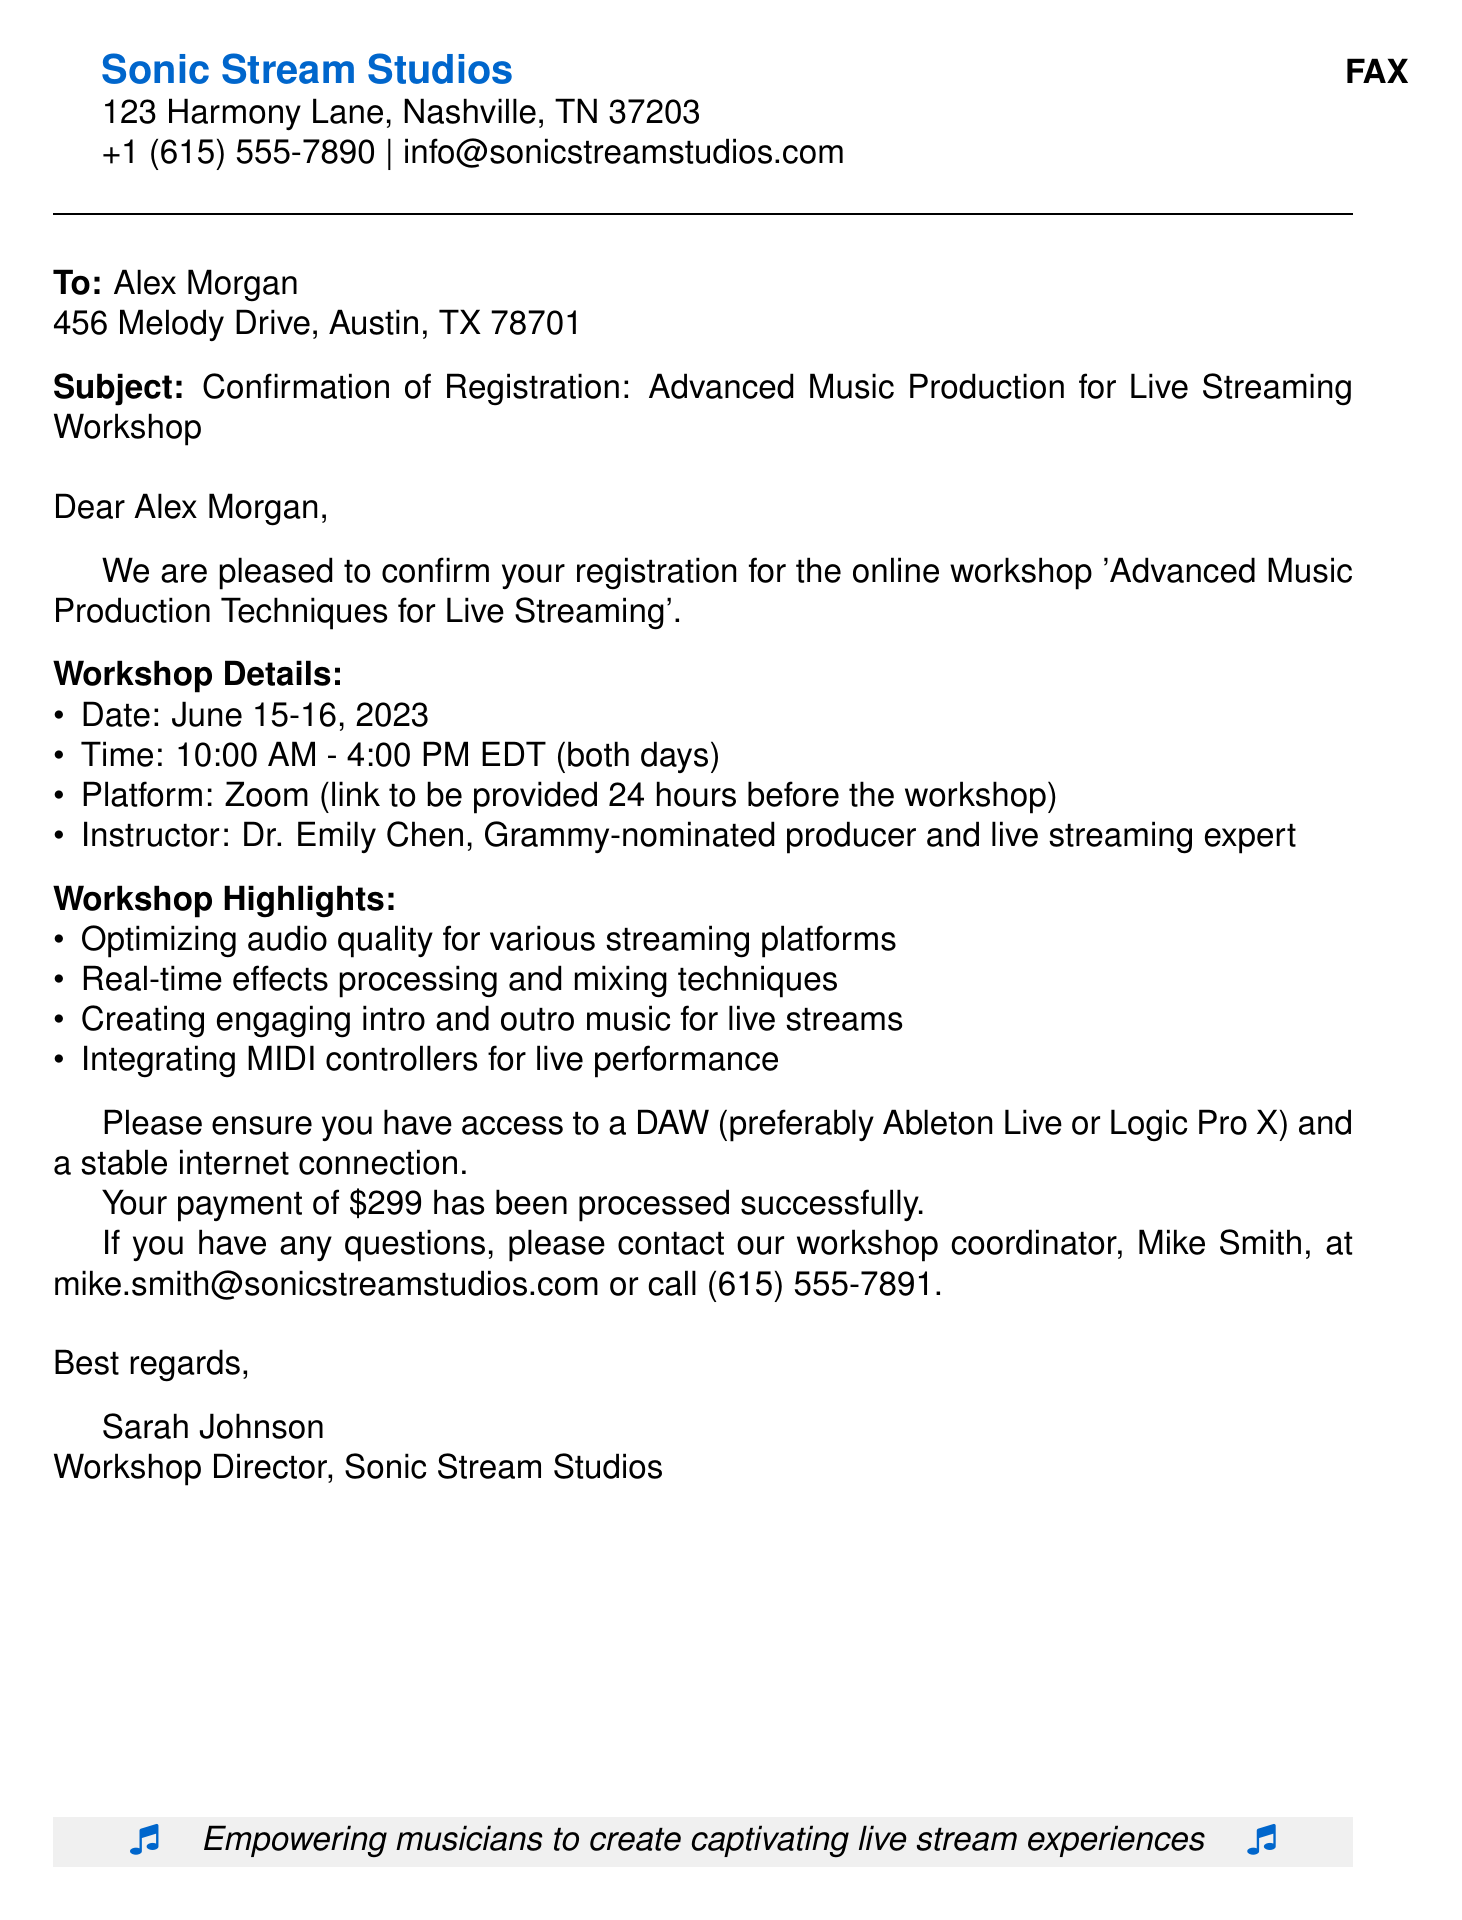What are the dates of the workshop? The document mentions the workshop will take place on June 15-16, 2023.
Answer: June 15-16, 2023 What is the cost of the workshop? The document states that the payment of $299 has been processed successfully.
Answer: $299 Who is the instructor for the workshop? The document specifies that the instructor is Dr. Emily Chen, a Grammy-nominated producer.
Answer: Dr. Emily Chen What platform will the workshop be held on? According to the document, the workshop will be conducted on Zoom.
Answer: Zoom What is one of the workshop highlights mentioned? The document lists several highlights, one being optimizing audio quality for various streaming platforms.
Answer: Optimizing audio quality for various streaming platforms How long will the workshop sessions be each day? The document indicates that the workshop sessions will run from 10:00 AM to 4:00 PM each day.
Answer: 6 hours What is the name of the workshop coordinator? The document provides the name of the workshop coordinator as Mike Smith.
Answer: Mike Smith What should participants ensure they have for the workshop? The document advises participants to have access to a DAW and a stable internet connection.
Answer: DAW and stable internet connection 